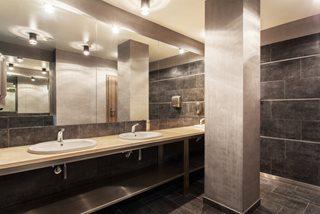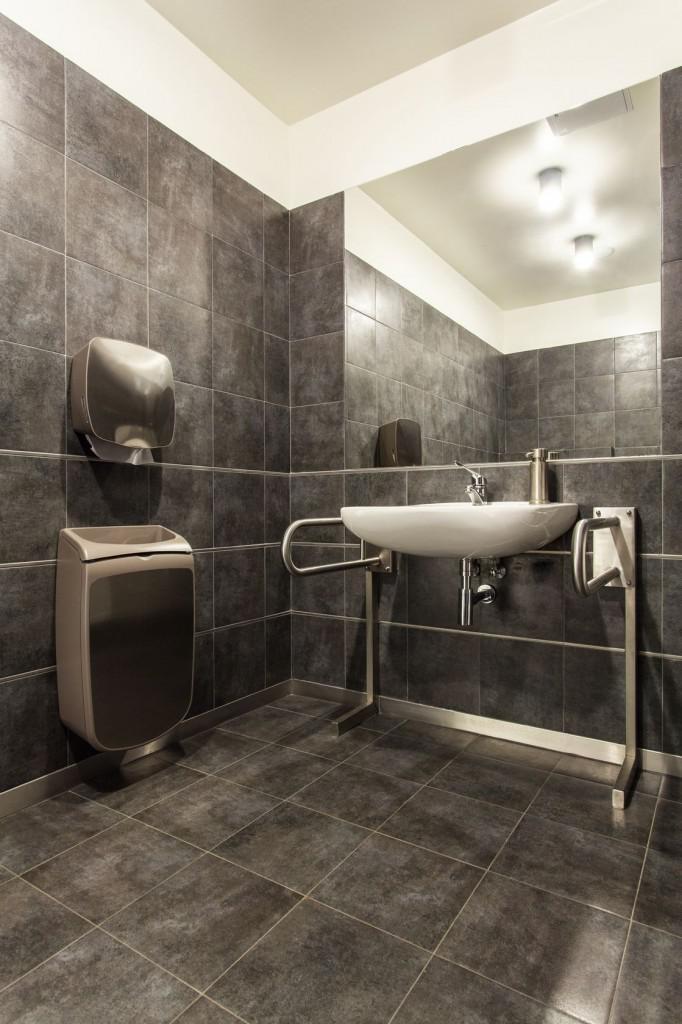The first image is the image on the left, the second image is the image on the right. Considering the images on both sides, is "An image shows a rectangular mirror above a rectangular double sinks on a white wall-mounted vanity, and one image features wall-mounted spouts above two sinks." valid? Answer yes or no. No. The first image is the image on the left, the second image is the image on the right. For the images shown, is this caption "At least one of the images has a window." true? Answer yes or no. No. 